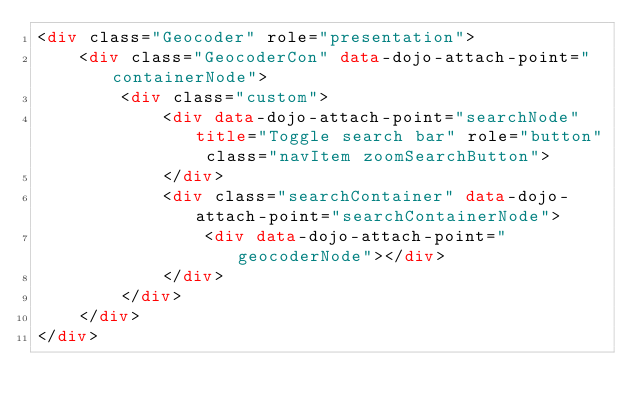Convert code to text. <code><loc_0><loc_0><loc_500><loc_500><_HTML_><div class="Geocoder" role="presentation">
    <div class="GeocoderCon" data-dojo-attach-point="containerNode">
        <div class="custom">
            <div data-dojo-attach-point="searchNode" title="Toggle search bar" role="button" class="navItem zoomSearchButton">
            </div>
            <div class="searchContainer" data-dojo-attach-point="searchContainerNode">
                <div data-dojo-attach-point="geocoderNode"></div>
            </div>
        </div>
    </div>
</div>
</code> 